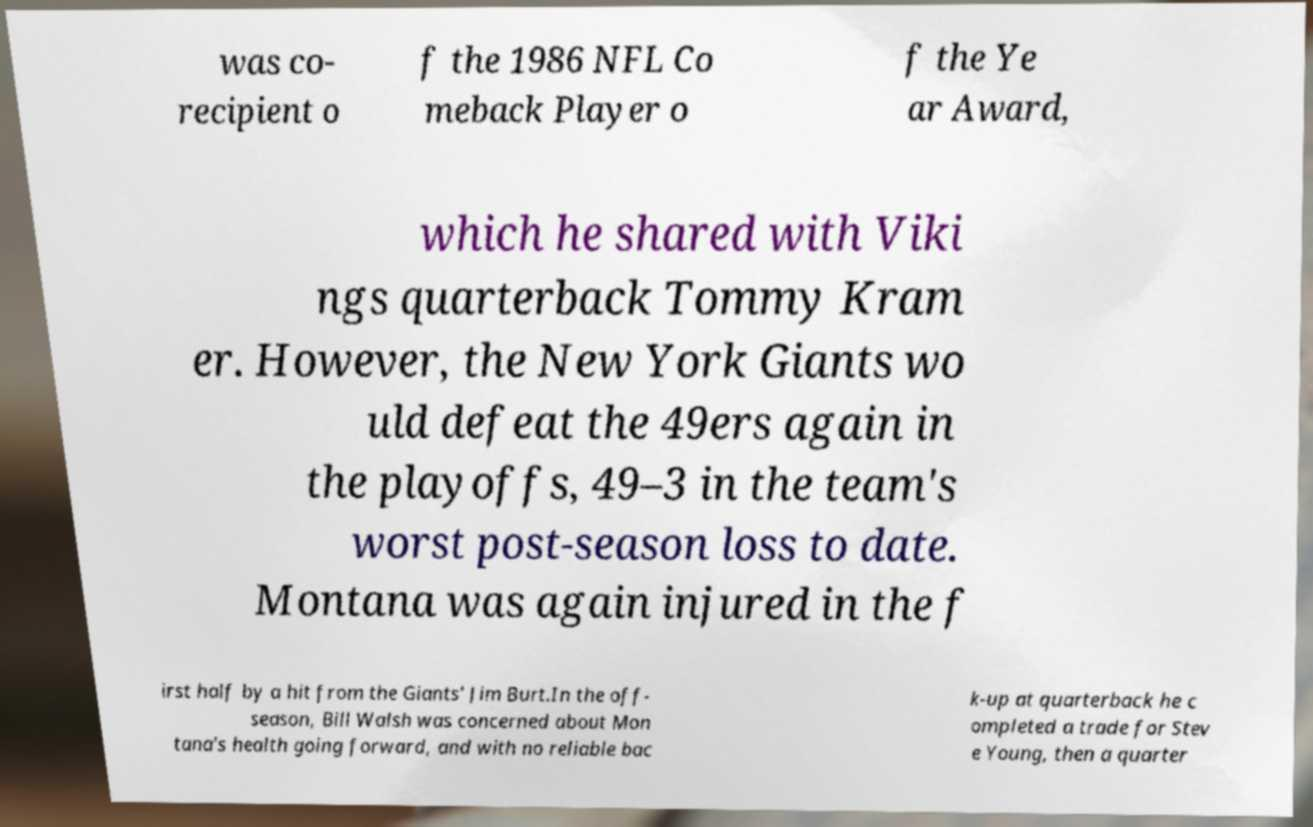Can you accurately transcribe the text from the provided image for me? was co- recipient o f the 1986 NFL Co meback Player o f the Ye ar Award, which he shared with Viki ngs quarterback Tommy Kram er. However, the New York Giants wo uld defeat the 49ers again in the playoffs, 49–3 in the team's worst post-season loss to date. Montana was again injured in the f irst half by a hit from the Giants' Jim Burt.In the off- season, Bill Walsh was concerned about Mon tana's health going forward, and with no reliable bac k-up at quarterback he c ompleted a trade for Stev e Young, then a quarter 